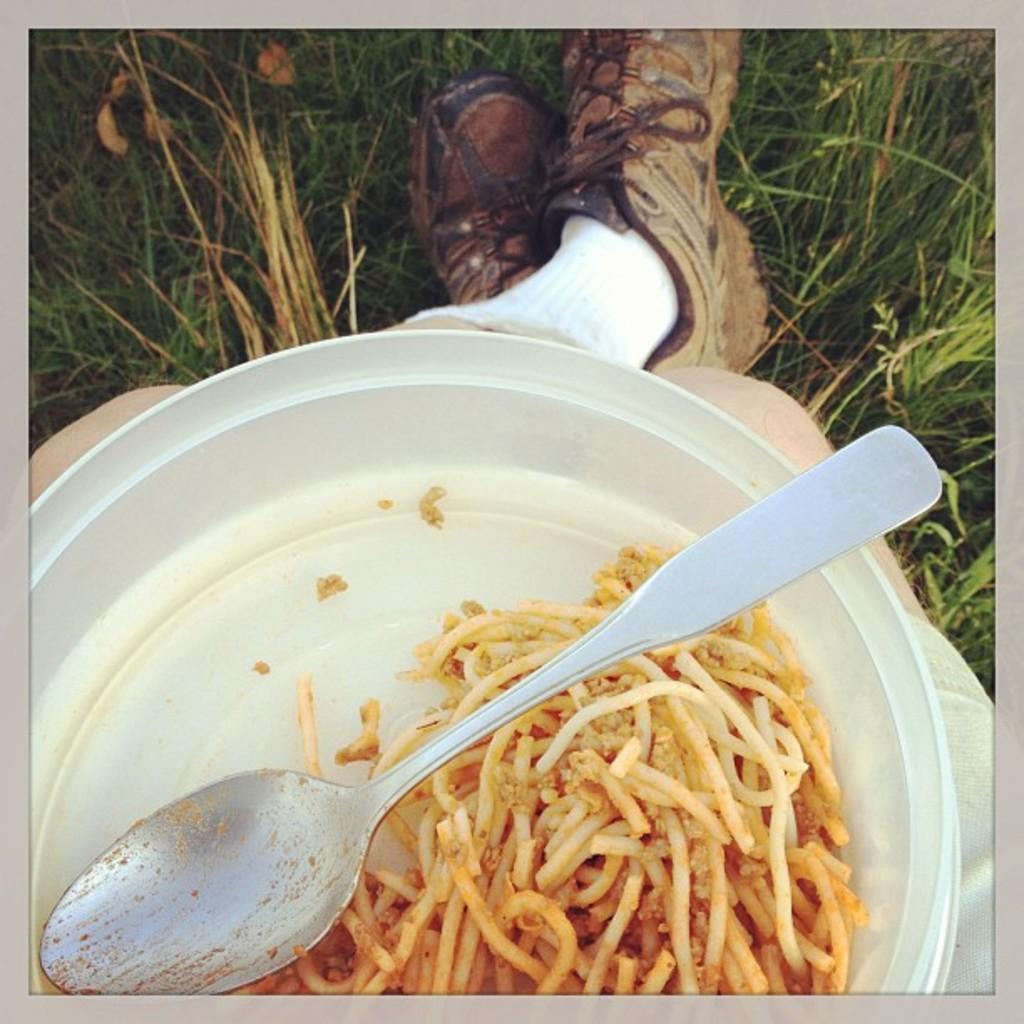What is the main subject of the image? There is a person sitting in the center of the image. What is the person holding in the image? The person is holding a plate. What can be seen in the plate? There is a spoon and noodles in the plate. What is visible in the background of the image? There is grass visible in the background of the image. What type of house is visible in the background of the image? There is no house visible in the background of the image; it features grass instead. What type of business is being conducted in the image? There is no business being conducted in the image; it shows a person sitting and holding a plate with noodles. 